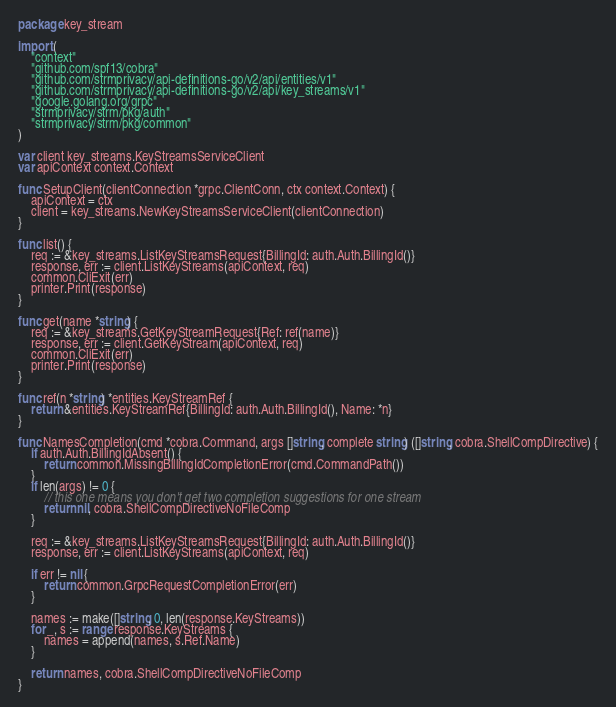Convert code to text. <code><loc_0><loc_0><loc_500><loc_500><_Go_>package key_stream

import (
	"context"
	"github.com/spf13/cobra"
	"github.com/strmprivacy/api-definitions-go/v2/api/entities/v1"
	"github.com/strmprivacy/api-definitions-go/v2/api/key_streams/v1"
	"google.golang.org/grpc"
	"strmprivacy/strm/pkg/auth"
	"strmprivacy/strm/pkg/common"
)

var client key_streams.KeyStreamsServiceClient
var apiContext context.Context

func SetupClient(clientConnection *grpc.ClientConn, ctx context.Context) {
	apiContext = ctx
	client = key_streams.NewKeyStreamsServiceClient(clientConnection)
}

func list() {
	req := &key_streams.ListKeyStreamsRequest{BillingId: auth.Auth.BillingId()}
	response, err := client.ListKeyStreams(apiContext, req)
	common.CliExit(err)
	printer.Print(response)
}

func get(name *string) {
	req := &key_streams.GetKeyStreamRequest{Ref: ref(name)}
	response, err := client.GetKeyStream(apiContext, req)
	common.CliExit(err)
	printer.Print(response)
}

func ref(n *string) *entities.KeyStreamRef {
	return &entities.KeyStreamRef{BillingId: auth.Auth.BillingId(), Name: *n}
}

func NamesCompletion(cmd *cobra.Command, args []string, complete string) ([]string, cobra.ShellCompDirective) {
	if auth.Auth.BillingIdAbsent() {
		return common.MissingBillingIdCompletionError(cmd.CommandPath())
	}
	if len(args) != 0 {
		// this one means you don't get two completion suggestions for one stream
		return nil, cobra.ShellCompDirectiveNoFileComp
	}

	req := &key_streams.ListKeyStreamsRequest{BillingId: auth.Auth.BillingId()}
	response, err := client.ListKeyStreams(apiContext, req)

	if err != nil {
		return common.GrpcRequestCompletionError(err)
	}

	names := make([]string, 0, len(response.KeyStreams))
	for _, s := range response.KeyStreams {
		names = append(names, s.Ref.Name)
	}

	return names, cobra.ShellCompDirectiveNoFileComp
}
</code> 